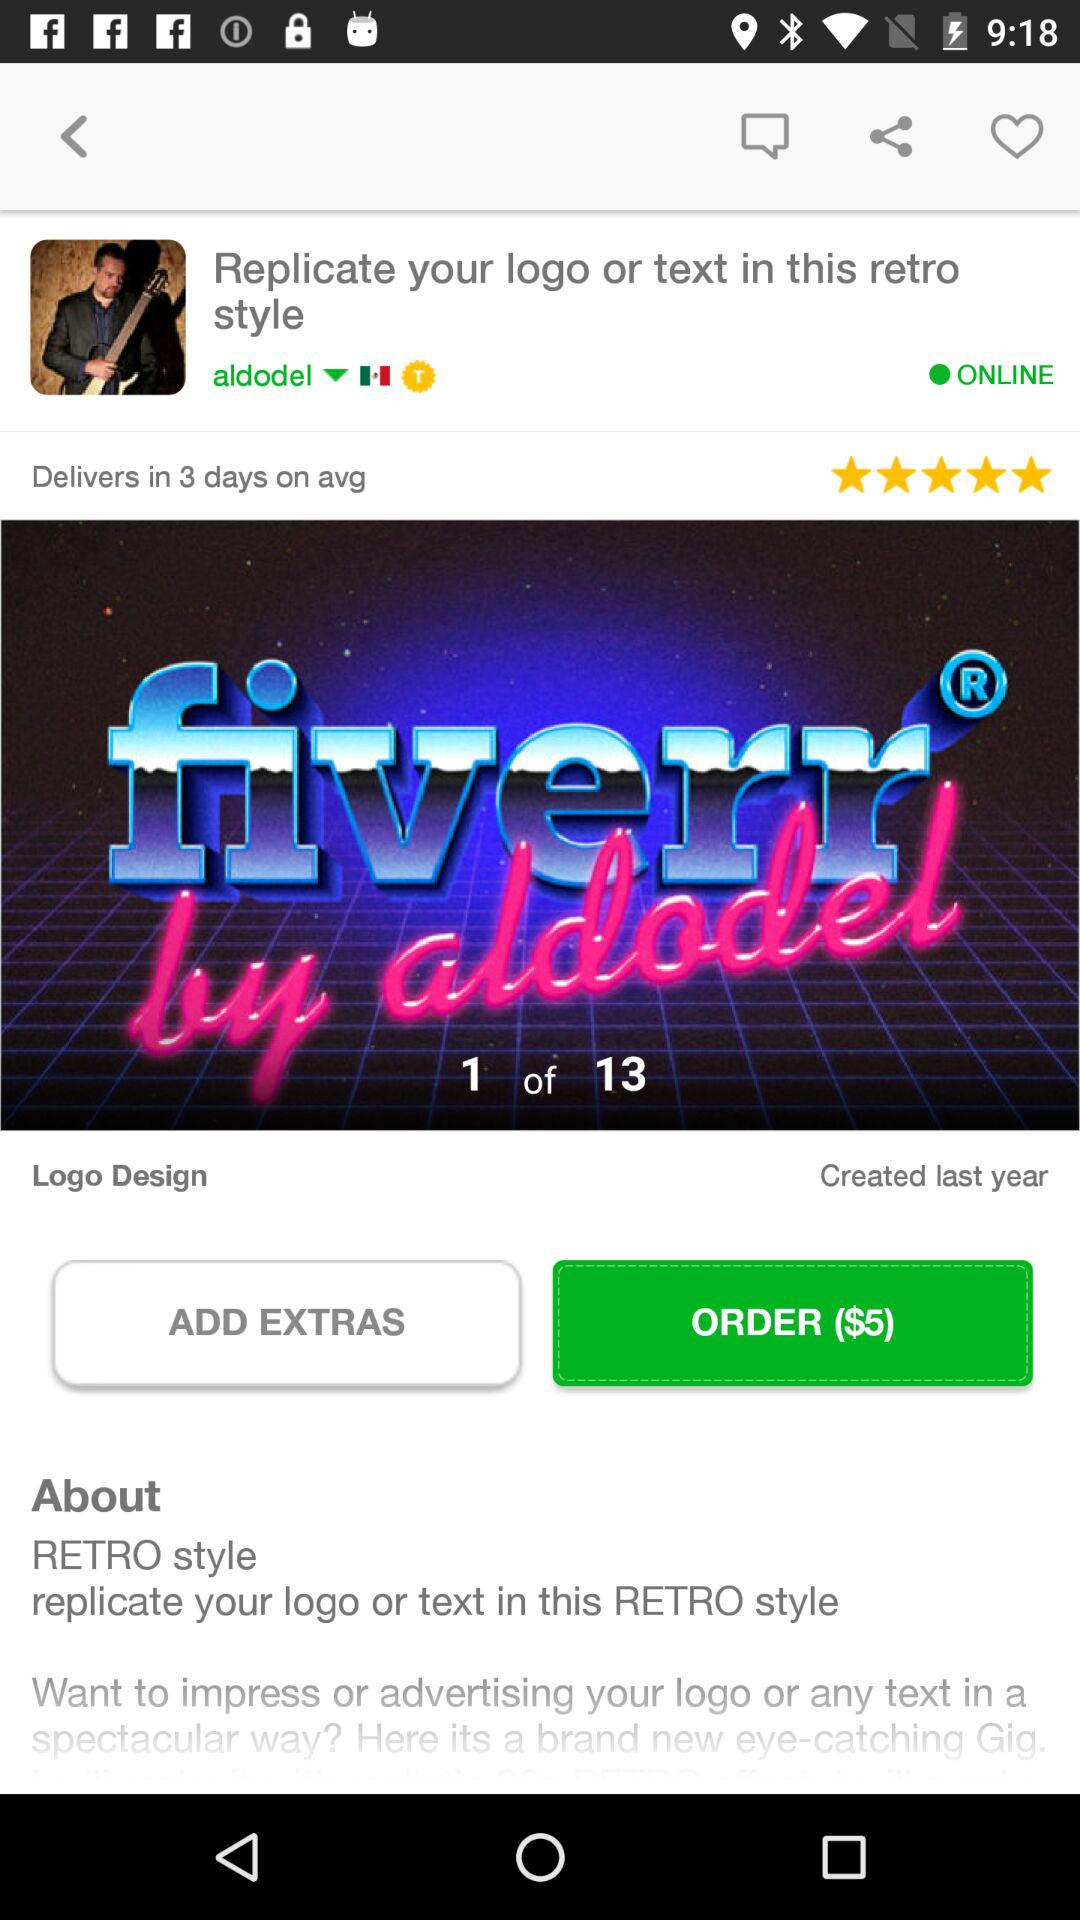What number of logo designs are shown? This is the first logo design on the screen. 